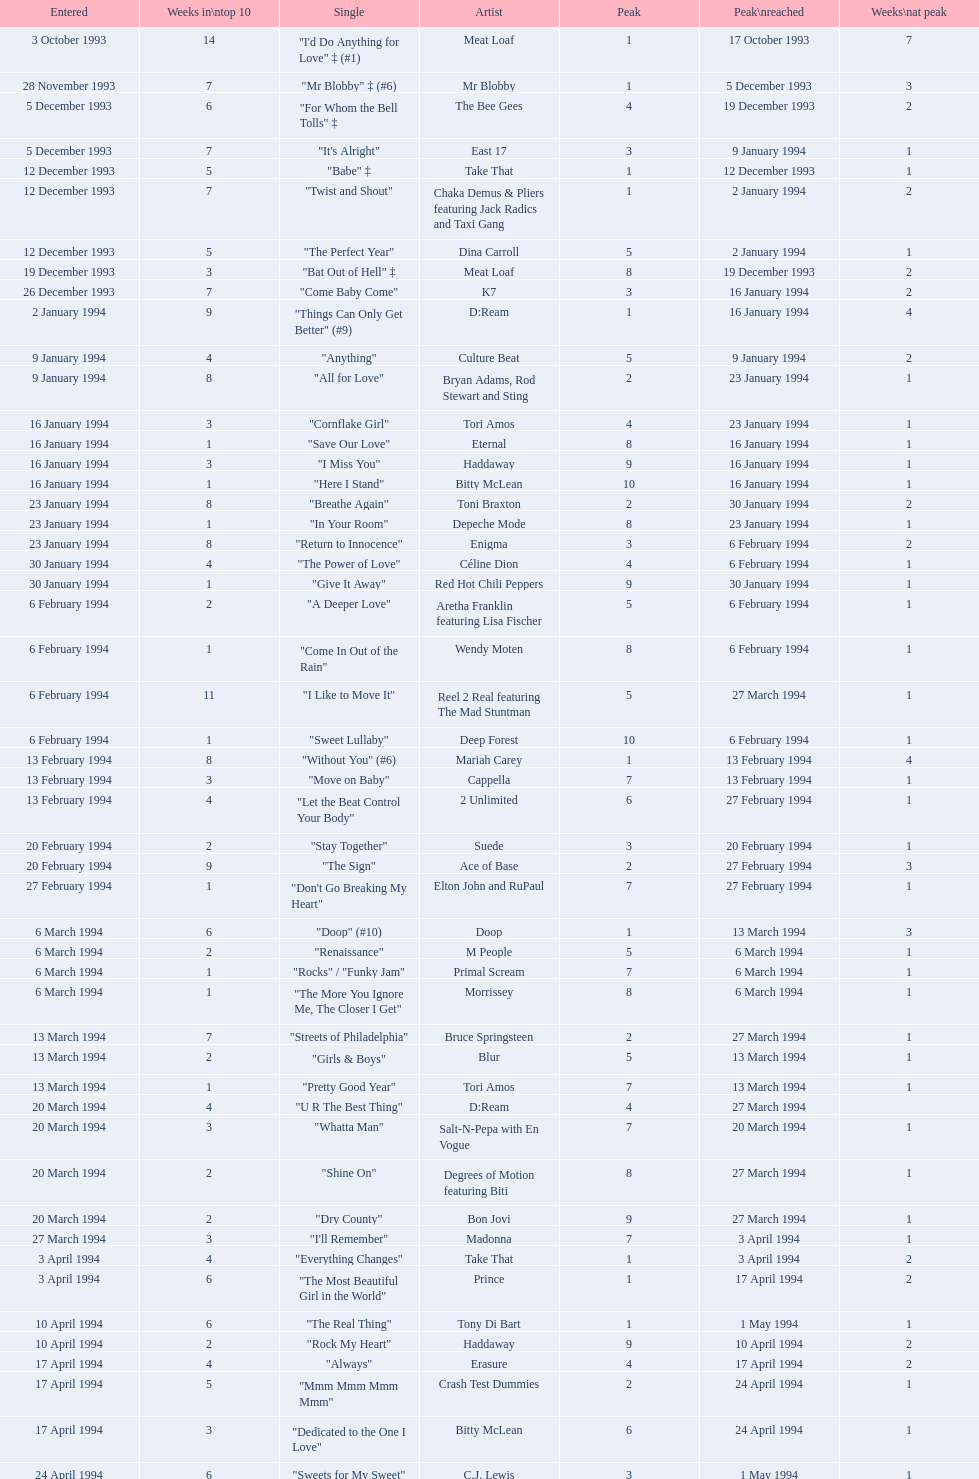Which single was the last one to be on the charts in 1993? "Come Baby Come". 